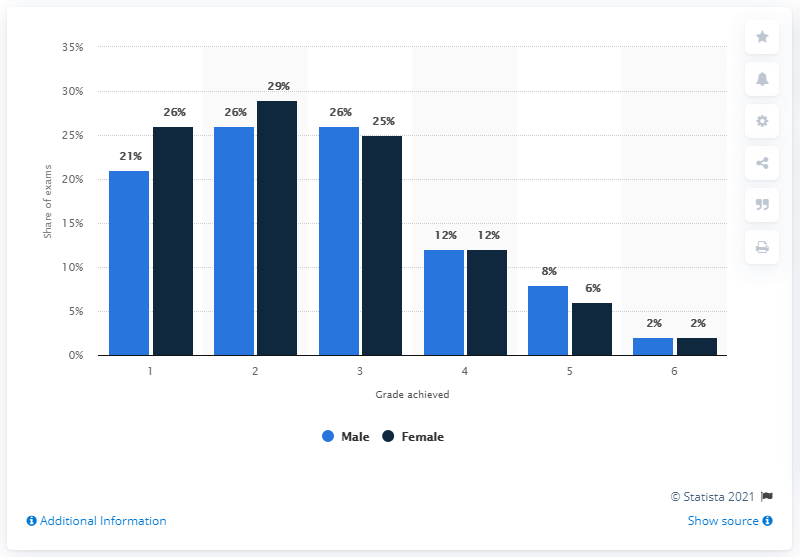Mention a couple of crucial points in this snapshot. The ratio of males in 4th and 5th grades is 1.5:1. There are two grades in which the number of male and female students is equal. The lowest passing grade is 6. The most common grade received was a 2. 